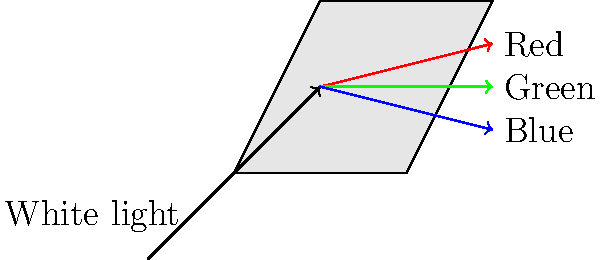In the context of the development of spectroscopy in scientific history, how did the refraction of light through a prism, as shown in the diagram, contribute to our understanding of the nature of light and its applications in investigative techniques? 1. Prism Refraction: When white light passes through a prism, it is refracted and dispersed into its component colors. This phenomenon is known as dispersion.

2. Newton's Contribution: Sir Isaac Newton first demonstrated this effect in 1666, showing that white light is composed of a spectrum of colors.

3. Spectral Analysis: This discovery laid the foundation for spectroscopy, a powerful analytical technique used in various scientific fields.

4. Fraunhofer Lines: In 1814, Joseph von Fraunhofer observed dark lines in the solar spectrum, later known as Fraunhofer lines. These lines are unique to each element, allowing for the identification of chemical compositions.

5. Applications in Astronomy: Spectroscopy became a crucial tool in astronomy, enabling scientists to determine the composition of distant stars and galaxies.

6. Forensic Science: In investigative work, spectroscopic techniques are used for analyzing trace evidence, such as in chemical analysis of substances found at crime scenes.

7. Environmental Monitoring: Spectroscopy is used to detect and measure pollutants in air and water, aiding in environmental investigations.

8. Historical Analysis: In historical research, spectroscopic techniques can be used to analyze the composition of artifacts, providing insights into their origin and age.

9. Medical Diagnostics: Spectroscopy has applications in medical diagnostics, which can be relevant for investigative reporting on public health issues.

10. Technological Advancements: The principles of spectroscopy have led to the development of various analytical instruments used in modern scientific investigations.
Answer: Prism refraction revealed light's spectral nature, enabling element identification and diverse analytical applications in science, forensics, and investigative techniques. 